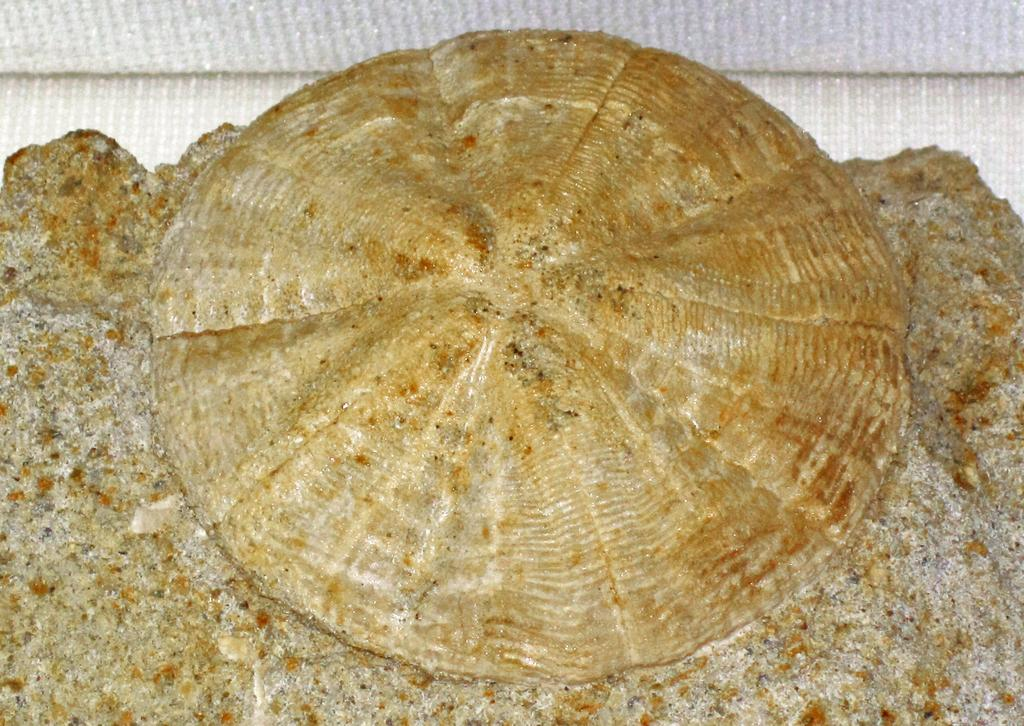What is the main subject of the image? There is an object in the image. Can you describe the appearance of the object? The object appears to be shell-like. What type of wood can be seen in the scene depicted in the image? There is no scene depicted in the image, and therefore no wood can be observed. 